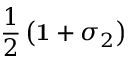Convert formula to latex. <formula><loc_0><loc_0><loc_500><loc_500>\frac { 1 } { 2 } \left ( { 1 } + \sigma _ { 2 } \right )</formula> 